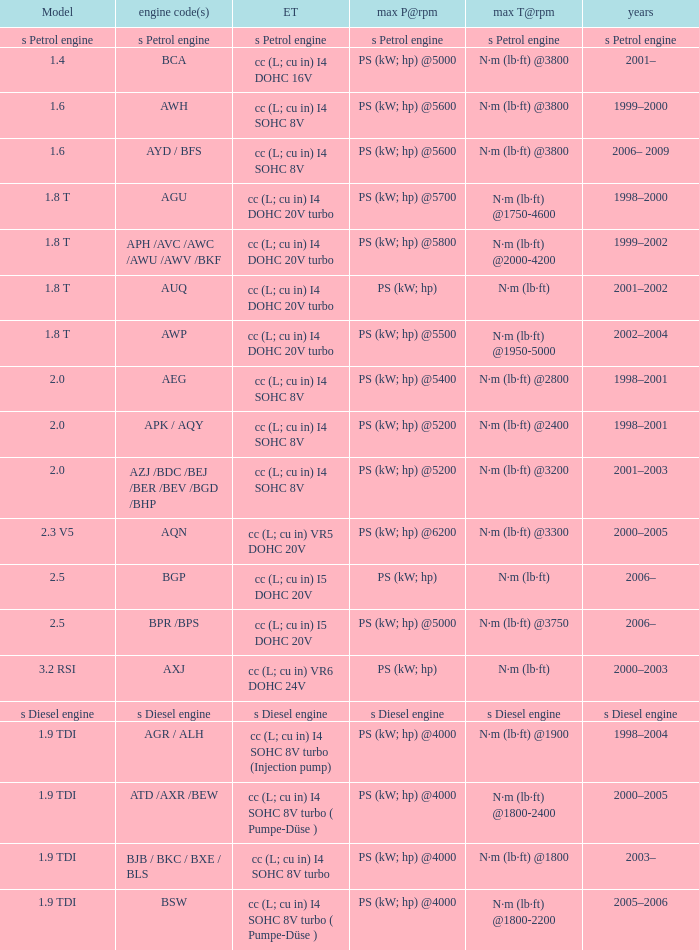What was the max torque@rpm of the engine which had the model 2.5  and a max power@rpm of ps (kw; hp) @5000? N·m (lb·ft) @3750. 